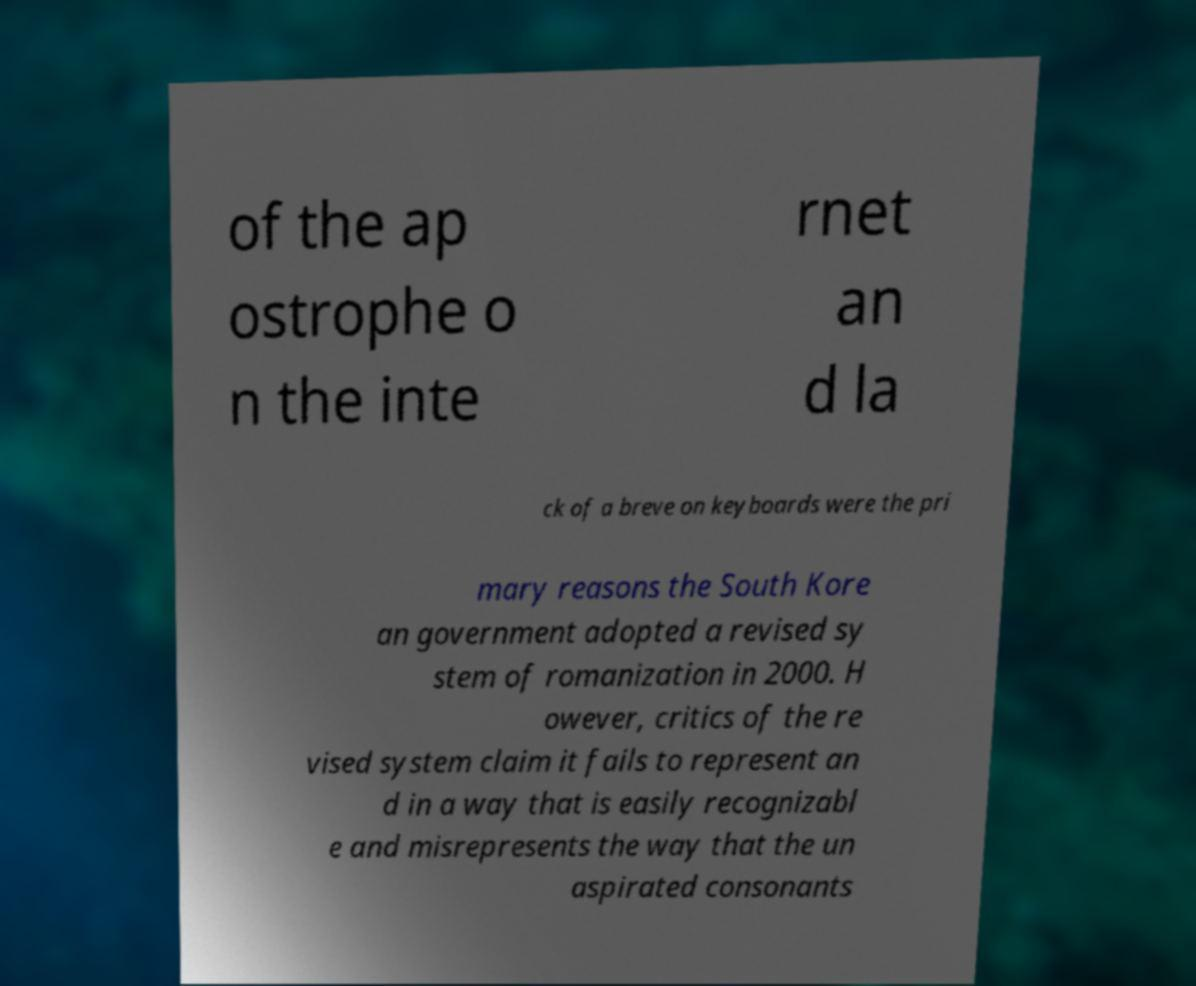I need the written content from this picture converted into text. Can you do that? of the ap ostrophe o n the inte rnet an d la ck of a breve on keyboards were the pri mary reasons the South Kore an government adopted a revised sy stem of romanization in 2000. H owever, critics of the re vised system claim it fails to represent an d in a way that is easily recognizabl e and misrepresents the way that the un aspirated consonants 